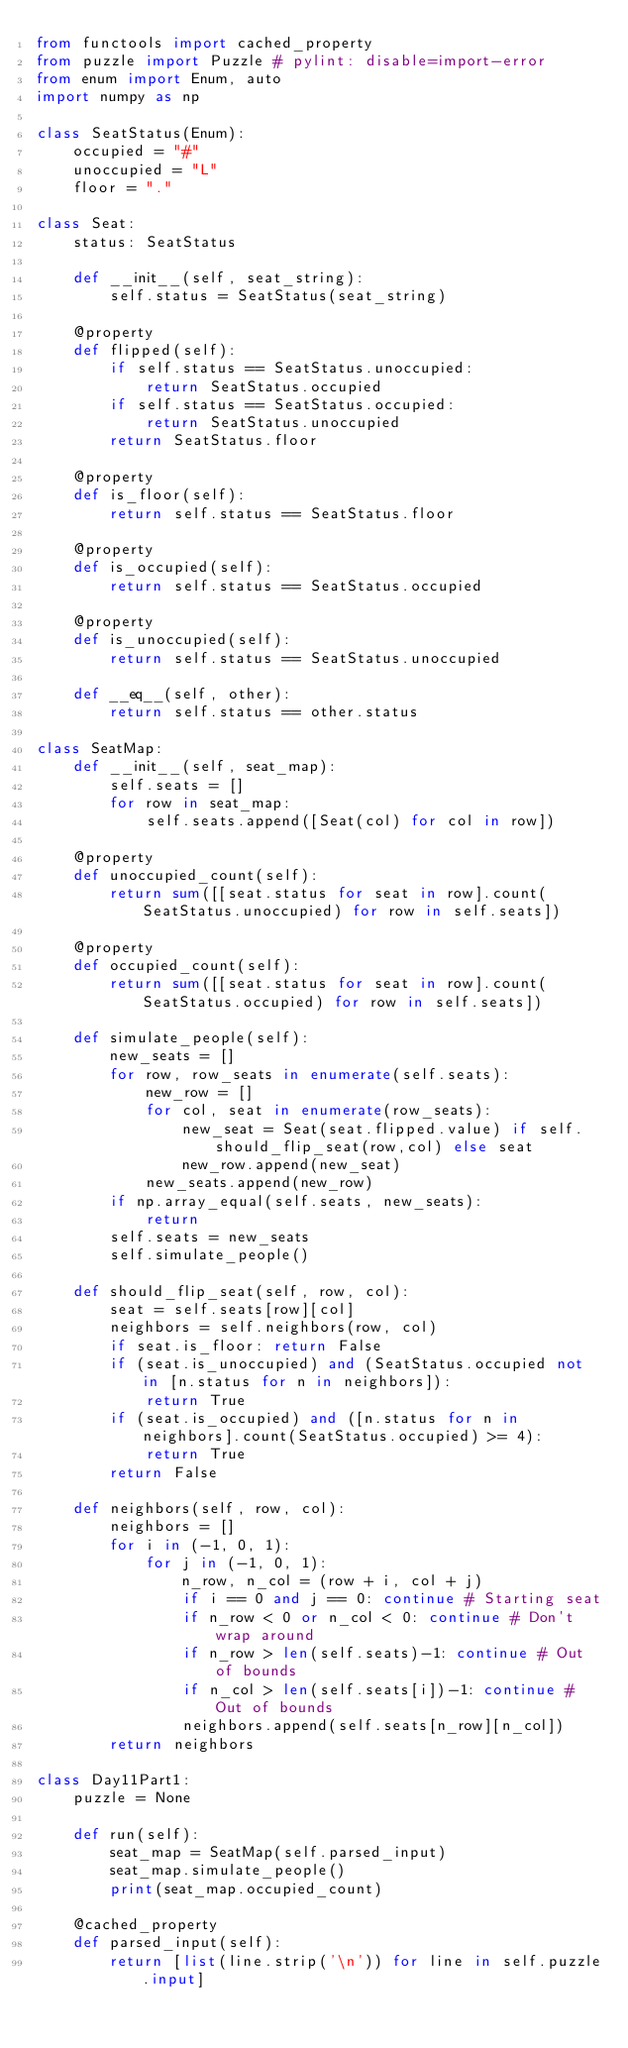<code> <loc_0><loc_0><loc_500><loc_500><_Python_>from functools import cached_property
from puzzle import Puzzle # pylint: disable=import-error
from enum import Enum, auto
import numpy as np

class SeatStatus(Enum):
    occupied = "#"
    unoccupied = "L"
    floor = "."
    
class Seat:
    status: SeatStatus

    def __init__(self, seat_string):
        self.status = SeatStatus(seat_string)

    @property
    def flipped(self):
        if self.status == SeatStatus.unoccupied:
            return SeatStatus.occupied
        if self.status == SeatStatus.occupied:
            return SeatStatus.unoccupied
        return SeatStatus.floor

    @property
    def is_floor(self):
        return self.status == SeatStatus.floor

    @property
    def is_occupied(self):
        return self.status == SeatStatus.occupied

    @property
    def is_unoccupied(self):
        return self.status == SeatStatus.unoccupied

    def __eq__(self, other):
        return self.status == other.status

class SeatMap:
    def __init__(self, seat_map):
        self.seats = []
        for row in seat_map:
            self.seats.append([Seat(col) for col in row])

    @property
    def unoccupied_count(self):
        return sum([[seat.status for seat in row].count(SeatStatus.unoccupied) for row in self.seats])

    @property
    def occupied_count(self):
        return sum([[seat.status for seat in row].count(SeatStatus.occupied) for row in self.seats])

    def simulate_people(self):
        new_seats = []
        for row, row_seats in enumerate(self.seats):
            new_row = []
            for col, seat in enumerate(row_seats):
                new_seat = Seat(seat.flipped.value) if self.should_flip_seat(row,col) else seat
                new_row.append(new_seat)
            new_seats.append(new_row)
        if np.array_equal(self.seats, new_seats):
            return
        self.seats = new_seats
        self.simulate_people()

    def should_flip_seat(self, row, col):
        seat = self.seats[row][col]
        neighbors = self.neighbors(row, col)
        if seat.is_floor: return False
        if (seat.is_unoccupied) and (SeatStatus.occupied not in [n.status for n in neighbors]):
            return True
        if (seat.is_occupied) and ([n.status for n in neighbors].count(SeatStatus.occupied) >= 4):
            return True
        return False

    def neighbors(self, row, col):
        neighbors = []
        for i in (-1, 0, 1):
            for j in (-1, 0, 1):
                n_row, n_col = (row + i, col + j)
                if i == 0 and j == 0: continue # Starting seat
                if n_row < 0 or n_col < 0: continue # Don't wrap around
                if n_row > len(self.seats)-1: continue # Out of bounds
                if n_col > len(self.seats[i])-1: continue # Out of bounds
                neighbors.append(self.seats[n_row][n_col])
        return neighbors

class Day11Part1:
    puzzle = None

    def run(self):
        seat_map = SeatMap(self.parsed_input)
        seat_map.simulate_people()
        print(seat_map.occupied_count)

    @cached_property
    def parsed_input(self):
        return [list(line.strip('\n')) for line in self.puzzle.input]
    </code> 